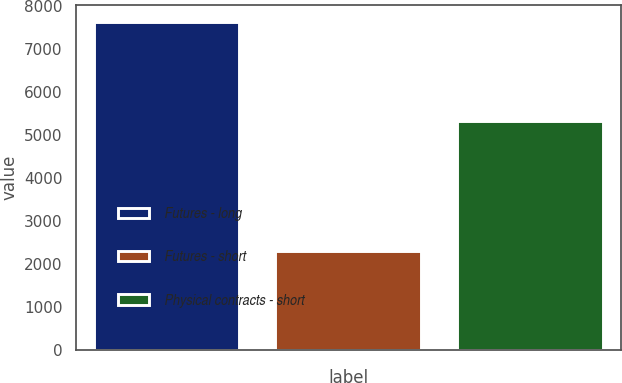Convert chart. <chart><loc_0><loc_0><loc_500><loc_500><bar_chart><fcel>Futures - long<fcel>Futures - short<fcel>Physical contracts - short<nl><fcel>7629<fcel>2314<fcel>5315<nl></chart> 